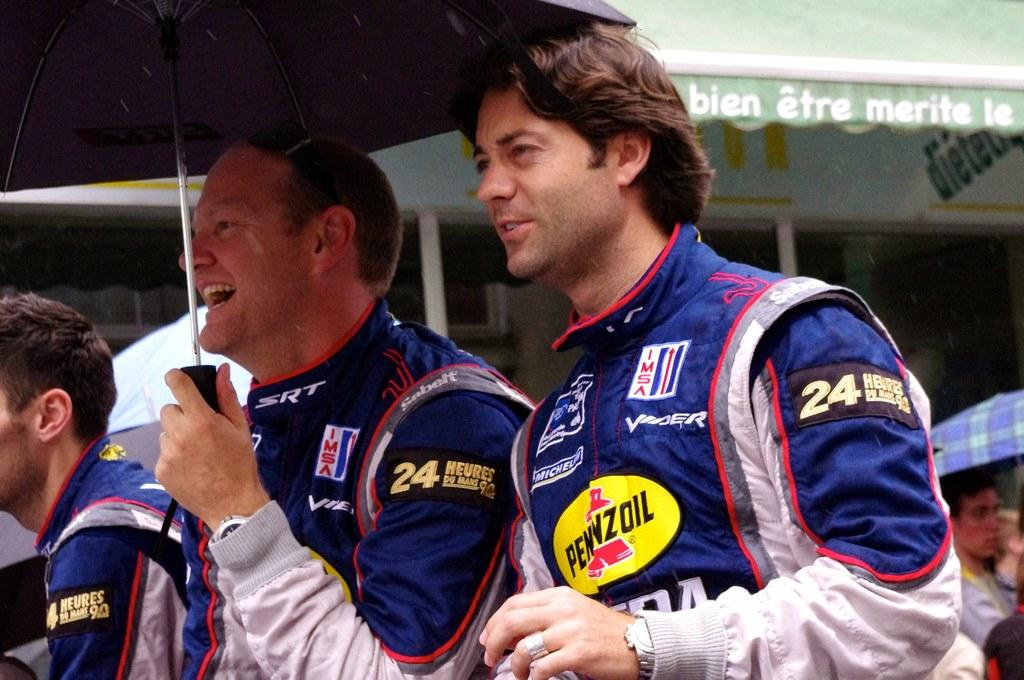Who or what can be seen in the image? There are people in the image. What objects are being used by the people in the image? There are umbrellas in the image. What type of structures are visible in the background? There are buildings in the image. Can you hear the thunder in the image? There is no mention of thunder or any audible elements in the image, so it cannot be heard. 